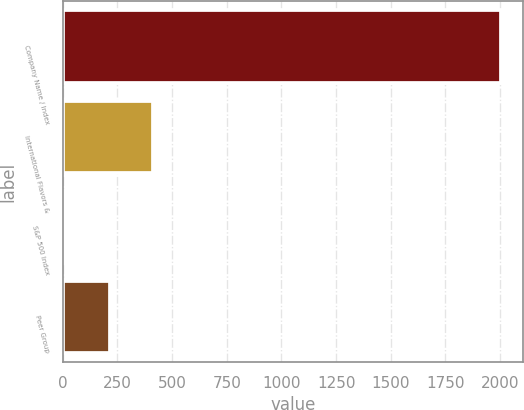Convert chart. <chart><loc_0><loc_0><loc_500><loc_500><bar_chart><fcel>Company Name / Index<fcel>International Flavors &<fcel>S&P 500 Index<fcel>Peer Group<nl><fcel>2006<fcel>413.83<fcel>15.79<fcel>214.81<nl></chart> 